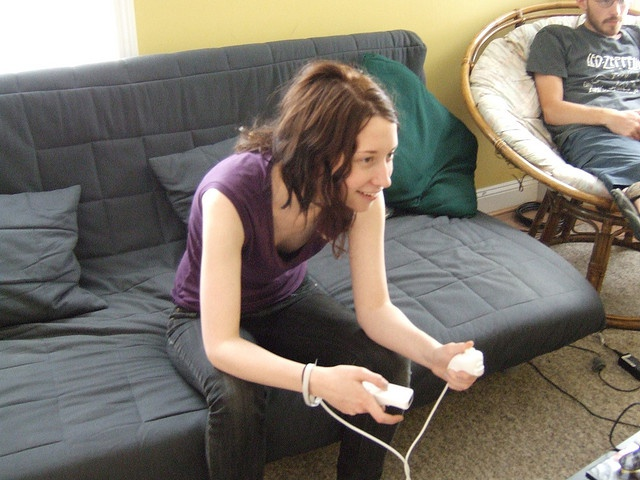Describe the objects in this image and their specific colors. I can see couch in white, gray, black, and darkgray tones, people in white, black, gray, tan, and maroon tones, chair in white, ivory, black, darkgray, and maroon tones, people in white, gray, darkgray, lightgray, and tan tones, and remote in white, darkgray, gray, and tan tones in this image. 